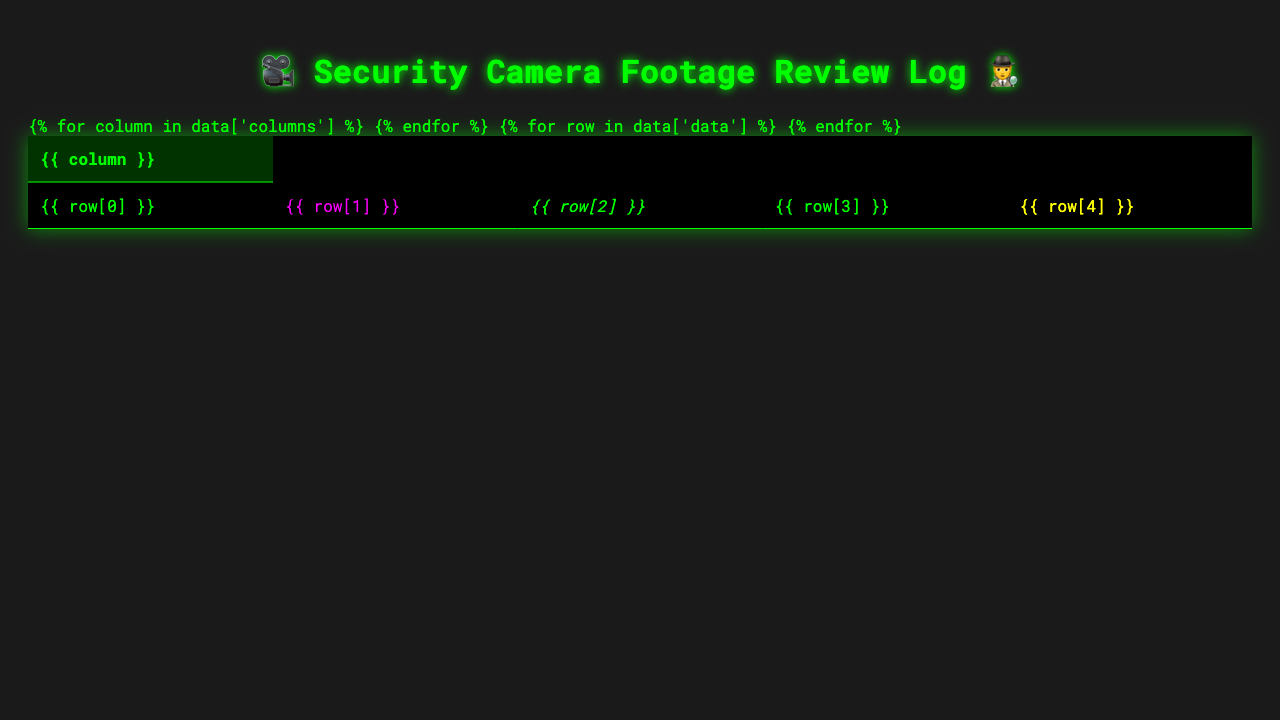What is the date of the attempted shoplifting incident? The log shows an entry for "Attempted shoplifting" under the "Activity" column, which corresponds to the date in the same row. This entry is found on the date "2023-05-02".
Answer: 2023-05-02 How many suspicious activities were reported in total? By counting the total number of entries in the data, I find there are 10 entries. Each entry corresponds to a distinct suspicious activity recorded.
Answer: 10 Which camera recorded the incident of graffiti in progress? The entry for "Graffiti in progress" specifies "Back Alley" under the "Camera" column. Thus, the "Back Alley" camera recorded this incident.
Answer: Back Alley What action was taken during the underage purchase attempt? Looking at the entry for "Underage purchase attempt," the "Action Taken" column states "ID checked and sale refused." This indicates the action taken was to check ID and refuse the sale.
Answer: ID checked and sale refused Was there any incident related to drug use? The table includes an entry labeled "Drug use suspected," which confirms that such an incident was indeed recorded.
Answer: Yes How many incidents resulted in a report being filed? Among the entries, there are two instances where a report was filed: "Suspicious transaction" and the "Attempted shoplifting." Therefore, I count these two.
Answer: 2 What time did the loitering incident occur? The log states that the incident of "Loitering group of teenagers" occurred at "23:15" on May 1, 2023, under the "Time" column.
Answer: 23:15 Which activity had the latest recorded time? Scanning through the table, the most recent time entry is "23:50" for the "Suspicious transaction" activity on May 9, 2023. This is the latest time recorded.
Answer: 23:50 What is the average time of day for the incidents reported? To find the average, the times in 24-hour format are converted to minutes since midnight: 23:15 (1395), 1:30 (90), 22:45 (1365), 3:20 (200), 0:10 (10), 2:55 (175), 21:30 (1290), 4:05 (245), 23:50 (1430), and 1:40 (100). Adding these gives a total of 9100 minutes, and dividing by 10 gives an average of 910 minutes, which corresponds to 15:10, or 3:10 PM.
Answer: 15:10 Which camera recorded the most incidents? By cross-referencing the "Camera" column for duplicate entries, "Store Entrance" has 2 incidents ("Attempted shoplifting" and "Suspicious transaction"), while all other cameras have 1 incident each. So, the Store Entrance recorded the most incidents.
Answer: Store Entrance 